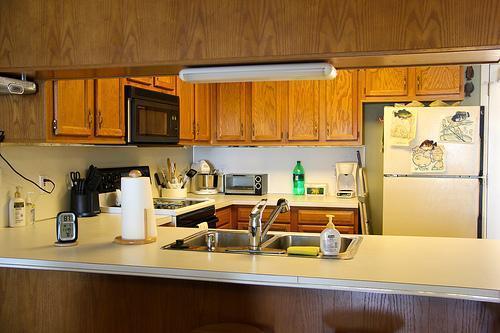How many pictures are on the fridge?
Give a very brief answer. 1. How many basins does the sink have?
Give a very brief answer. 2. How many cabinet doors are shown?
Give a very brief answer. 12. How many pictures are on the refrigerator?
Give a very brief answer. 3. 